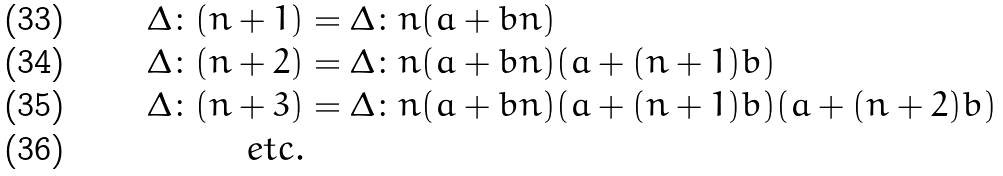Convert formula to latex. <formula><loc_0><loc_0><loc_500><loc_500>\Delta \colon ( n + 1 ) & = \Delta \colon n ( a + b n ) \\ \Delta \colon ( n + 2 ) & = \Delta \colon n ( a + b n ) ( a + ( n + 1 ) b ) \\ \Delta \colon ( n + 3 ) & = \Delta \colon n ( a + b n ) ( a + ( n + 1 ) b ) ( a + ( n + 2 ) b ) \\ e t c . &</formula> 